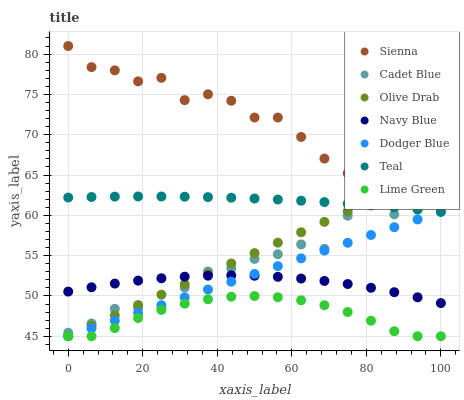Does Lime Green have the minimum area under the curve?
Answer yes or no. Yes. Does Sienna have the maximum area under the curve?
Answer yes or no. Yes. Does Navy Blue have the minimum area under the curve?
Answer yes or no. No. Does Navy Blue have the maximum area under the curve?
Answer yes or no. No. Is Olive Drab the smoothest?
Answer yes or no. Yes. Is Sienna the roughest?
Answer yes or no. Yes. Is Navy Blue the smoothest?
Answer yes or no. No. Is Navy Blue the roughest?
Answer yes or no. No. Does Dodger Blue have the lowest value?
Answer yes or no. Yes. Does Navy Blue have the lowest value?
Answer yes or no. No. Does Sienna have the highest value?
Answer yes or no. Yes. Does Navy Blue have the highest value?
Answer yes or no. No. Is Dodger Blue less than Sienna?
Answer yes or no. Yes. Is Teal greater than Lime Green?
Answer yes or no. Yes. Does Navy Blue intersect Cadet Blue?
Answer yes or no. Yes. Is Navy Blue less than Cadet Blue?
Answer yes or no. No. Is Navy Blue greater than Cadet Blue?
Answer yes or no. No. Does Dodger Blue intersect Sienna?
Answer yes or no. No. 